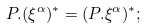<formula> <loc_0><loc_0><loc_500><loc_500>P . ( \xi ^ { \alpha } ) ^ { \ast } = ( P . \xi ^ { \alpha } ) ^ { \ast } ;</formula> 